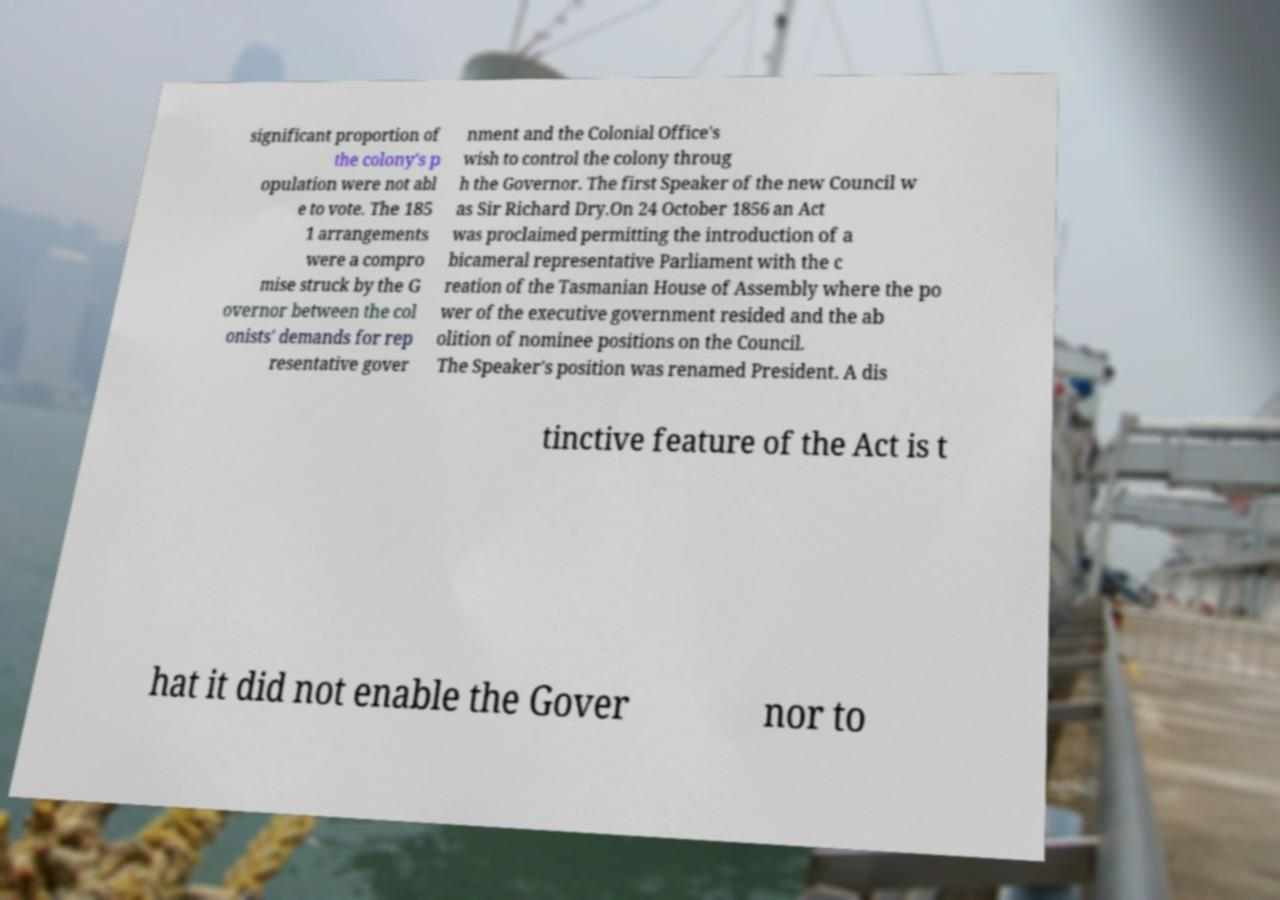Could you extract and type out the text from this image? significant proportion of the colony's p opulation were not abl e to vote. The 185 1 arrangements were a compro mise struck by the G overnor between the col onists' demands for rep resentative gover nment and the Colonial Office's wish to control the colony throug h the Governor. The first Speaker of the new Council w as Sir Richard Dry.On 24 October 1856 an Act was proclaimed permitting the introduction of a bicameral representative Parliament with the c reation of the Tasmanian House of Assembly where the po wer of the executive government resided and the ab olition of nominee positions on the Council. The Speaker's position was renamed President. A dis tinctive feature of the Act is t hat it did not enable the Gover nor to 